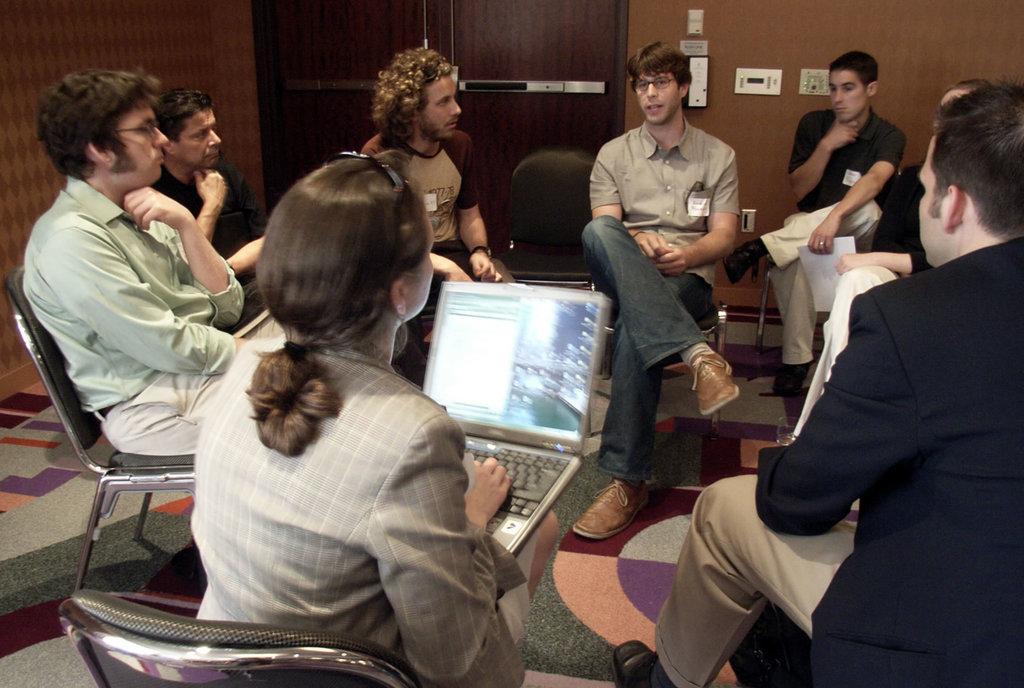How would you summarize this image in a sentence or two? In this image there are people sitting on chairs, one lady is holding a laptop in her hands, in the background there is a wall for that wall there is a door. 